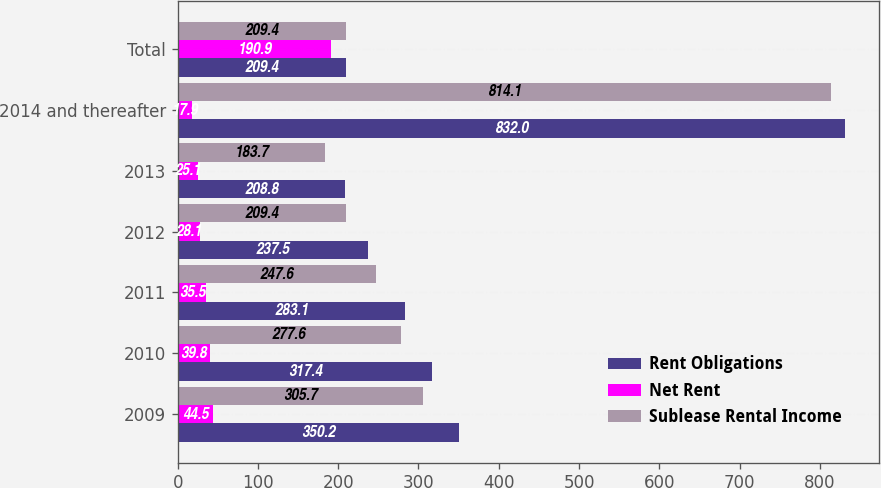<chart> <loc_0><loc_0><loc_500><loc_500><stacked_bar_chart><ecel><fcel>2009<fcel>2010<fcel>2011<fcel>2012<fcel>2013<fcel>2014 and thereafter<fcel>Total<nl><fcel>Rent Obligations<fcel>350.2<fcel>317.4<fcel>283.1<fcel>237.5<fcel>208.8<fcel>832<fcel>209.4<nl><fcel>Net Rent<fcel>44.5<fcel>39.8<fcel>35.5<fcel>28.1<fcel>25.1<fcel>17.9<fcel>190.9<nl><fcel>Sublease Rental Income<fcel>305.7<fcel>277.6<fcel>247.6<fcel>209.4<fcel>183.7<fcel>814.1<fcel>209.4<nl></chart> 